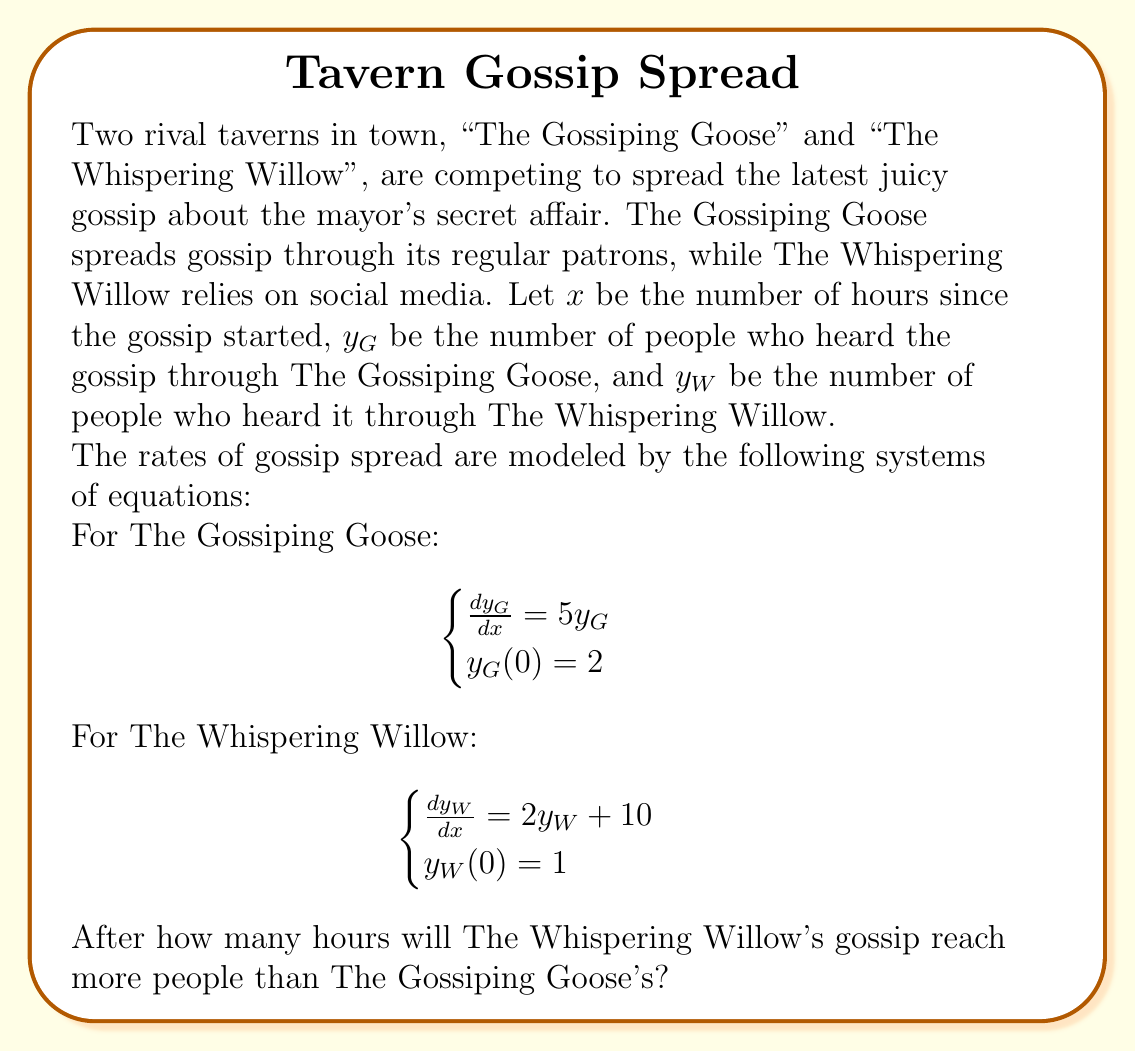Give your solution to this math problem. To solve this problem, we need to find the solutions for both systems of equations and then compare them.

1. For The Gossiping Goose:
   The differential equation $\frac{dy_G}{dx} = 5y_G$ with initial condition $y_G(0) = 2$ is a simple exponential growth model.
   The solution is: $y_G = 2e^{5x}$

2. For The Whispering Willow:
   The differential equation $\frac{dy_W}{dx} = 2y_W + 10$ with initial condition $y_W(0) = 1$ is a linear first-order ODE.
   The solution is: $y_W = 5(e^{2x} - 1) + e^{2x} = 5e^{2x} - 5$

3. To find when The Whispering Willow's gossip reaches more people, we need to solve:
   $5e^{2x} - 5 > 2e^{5x}$

4. This inequality doesn't have a simple algebraic solution, so we'll use numerical methods or graphing to find the intersection point.

5. Using a graphing calculator or computer algebra system, we can find that the curves intersect at approximately $x = 0.8642$ hours.

6. After this point, The Whispering Willow's gossip will reach more people.
Answer: The Whispering Willow's gossip will reach more people than The Gossiping Goose's after approximately 0.86 hours (about 52 minutes). 